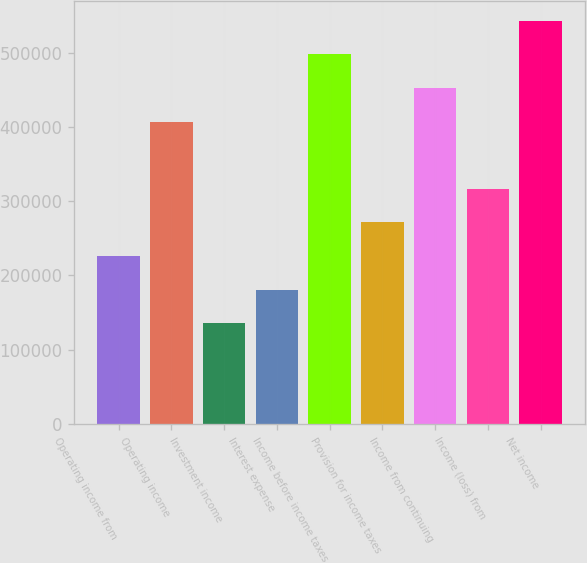Convert chart to OTSL. <chart><loc_0><loc_0><loc_500><loc_500><bar_chart><fcel>Operating income from<fcel>Operating income<fcel>Investment income<fcel>Interest expense<fcel>Income before income taxes<fcel>Provision for income taxes<fcel>Income from continuing<fcel>Income (loss) from<fcel>Net income<nl><fcel>226285<fcel>407312<fcel>135771<fcel>181028<fcel>497826<fcel>271542<fcel>452569<fcel>316799<fcel>543083<nl></chart> 